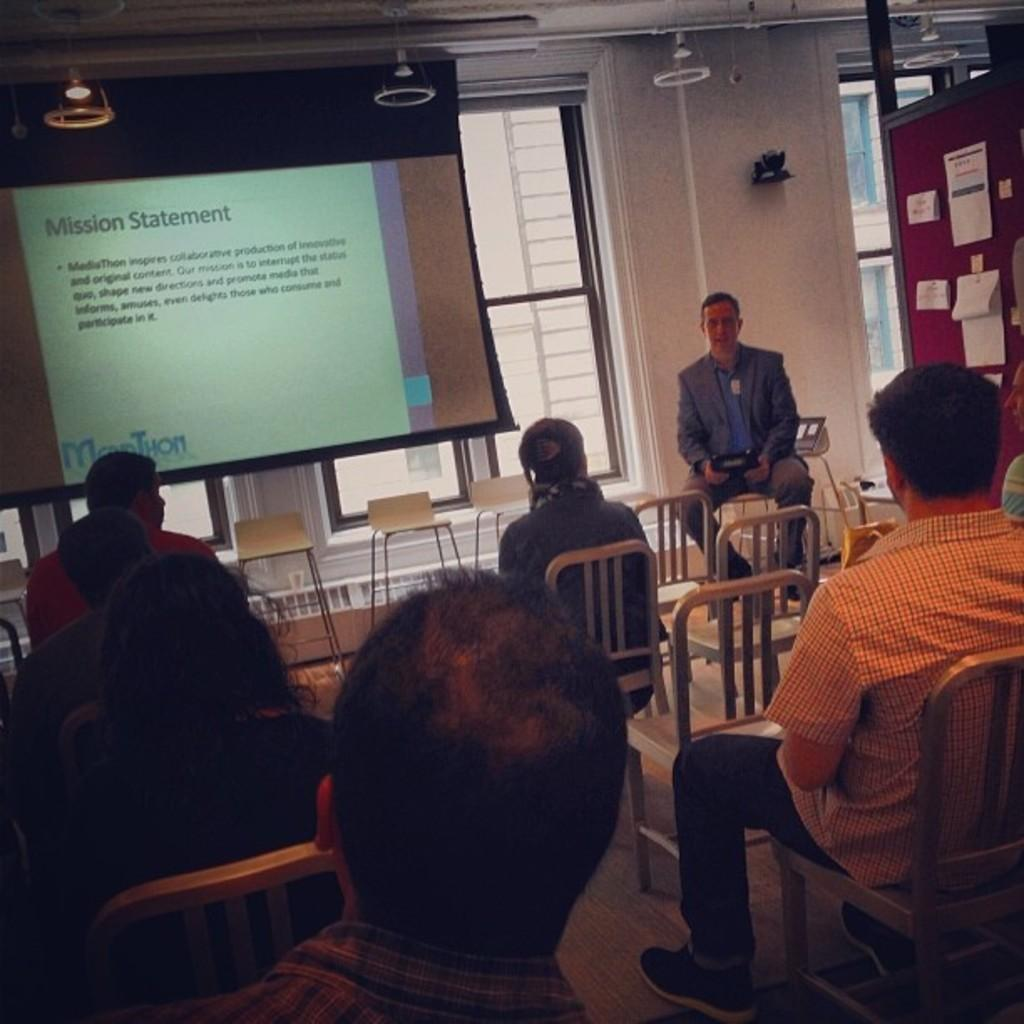How many people are in the image? There is a group of people in the image. What are the people doing in the image? The people are sitting in chairs and listening to a lecture. Who is giving the lecture in the image? The lecture is being given by a man. What is present in the room to aid the lecture? There is a big screen in the room. What verse is being recited by the people in the image? There is no verse being recited in the image; the people are listening to a lecture. 